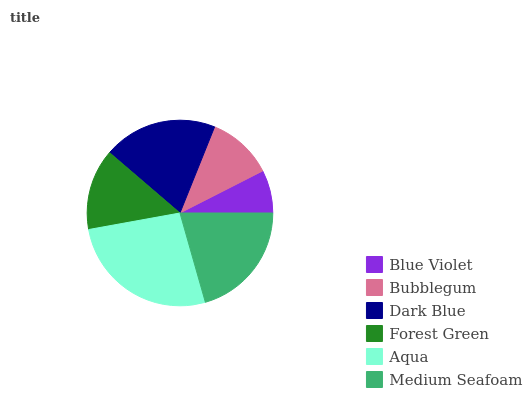Is Blue Violet the minimum?
Answer yes or no. Yes. Is Aqua the maximum?
Answer yes or no. Yes. Is Bubblegum the minimum?
Answer yes or no. No. Is Bubblegum the maximum?
Answer yes or no. No. Is Bubblegum greater than Blue Violet?
Answer yes or no. Yes. Is Blue Violet less than Bubblegum?
Answer yes or no. Yes. Is Blue Violet greater than Bubblegum?
Answer yes or no. No. Is Bubblegum less than Blue Violet?
Answer yes or no. No. Is Dark Blue the high median?
Answer yes or no. Yes. Is Forest Green the low median?
Answer yes or no. Yes. Is Medium Seafoam the high median?
Answer yes or no. No. Is Aqua the low median?
Answer yes or no. No. 